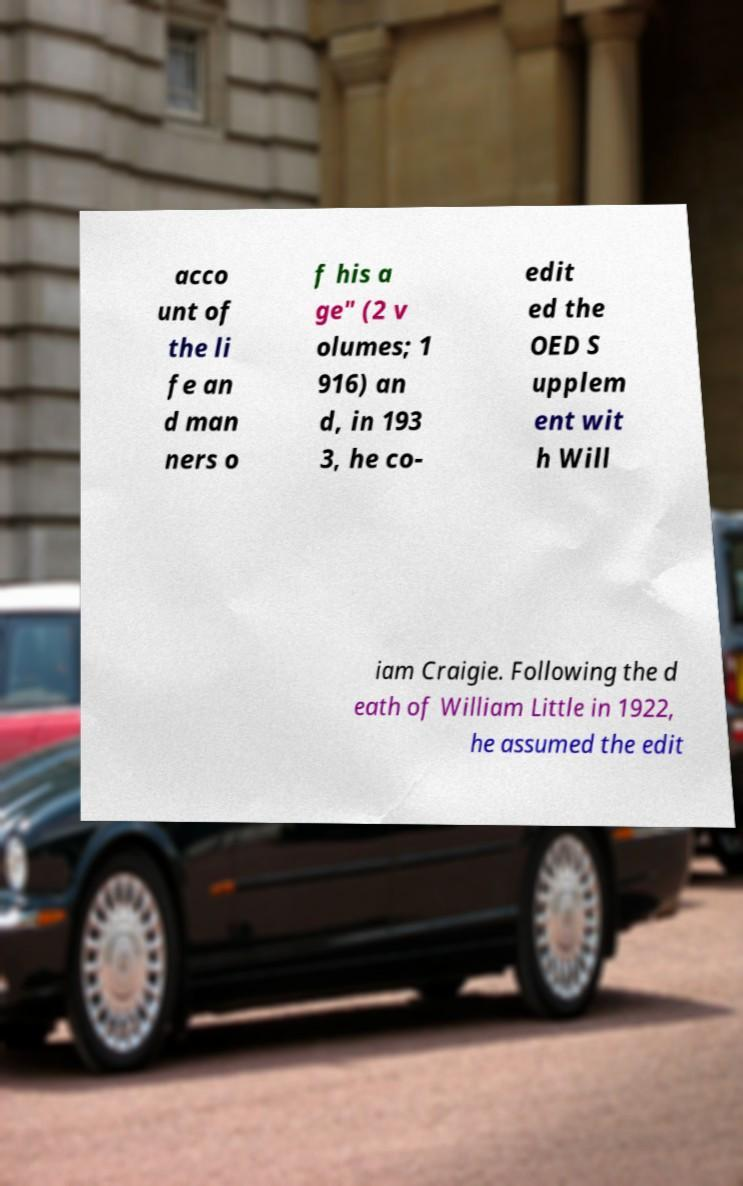For documentation purposes, I need the text within this image transcribed. Could you provide that? acco unt of the li fe an d man ners o f his a ge" (2 v olumes; 1 916) an d, in 193 3, he co- edit ed the OED S upplem ent wit h Will iam Craigie. Following the d eath of William Little in 1922, he assumed the edit 